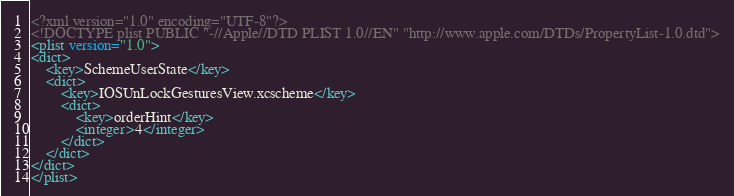<code> <loc_0><loc_0><loc_500><loc_500><_XML_><?xml version="1.0" encoding="UTF-8"?>
<!DOCTYPE plist PUBLIC "-//Apple//DTD PLIST 1.0//EN" "http://www.apple.com/DTDs/PropertyList-1.0.dtd">
<plist version="1.0">
<dict>
	<key>SchemeUserState</key>
	<dict>
		<key>IOSUnLockGesturesView.xcscheme</key>
		<dict>
			<key>orderHint</key>
			<integer>4</integer>
		</dict>
	</dict>
</dict>
</plist>
</code> 